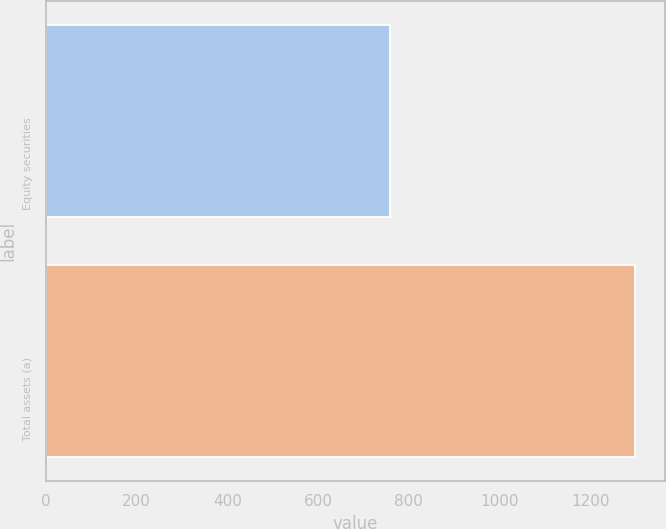Convert chart to OTSL. <chart><loc_0><loc_0><loc_500><loc_500><bar_chart><fcel>Equity securities<fcel>Total assets (a)<nl><fcel>759<fcel>1300<nl></chart> 